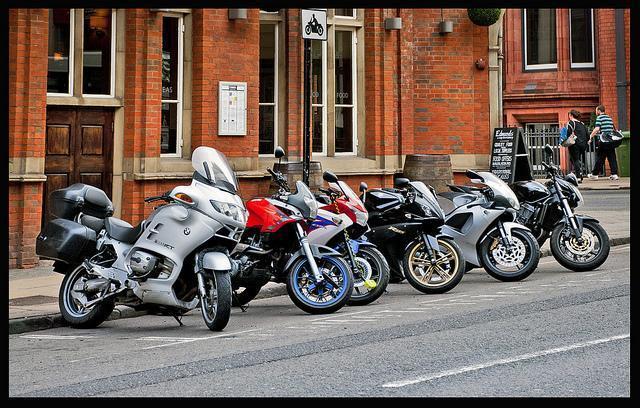How many people are walking?
Give a very brief answer. 2. How many bikes are there?
Give a very brief answer. 6. How many motorcycles can you see?
Give a very brief answer. 6. How many cows a man is holding?
Give a very brief answer. 0. 